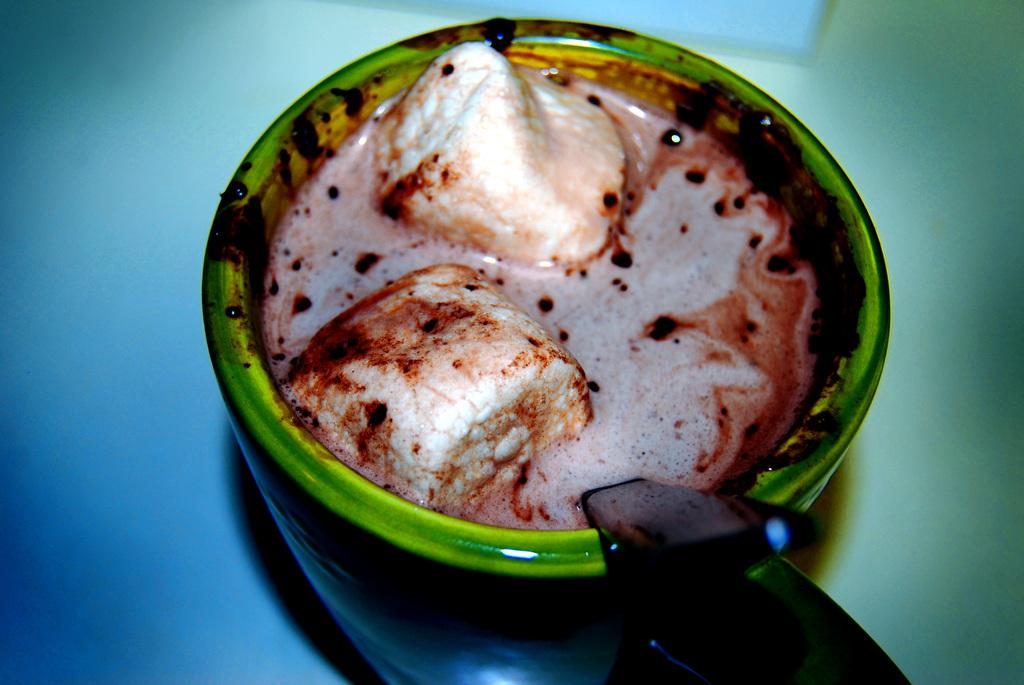What is contained in the cup that is visible in the image? There is food in a cup in the image. Can you describe the colors of the food in the cup? The food has white, cream, and brown colors. What utensil is present in the image? There is a spoon in the image. What color is the background of the image? The background of the image is blue. Are there any fairies visible in the image? There are no fairies present in the image. What type of cup is used to hold the food in the image? The provided facts do not specify the type of cup used to hold the food, only that there is a cup present. 